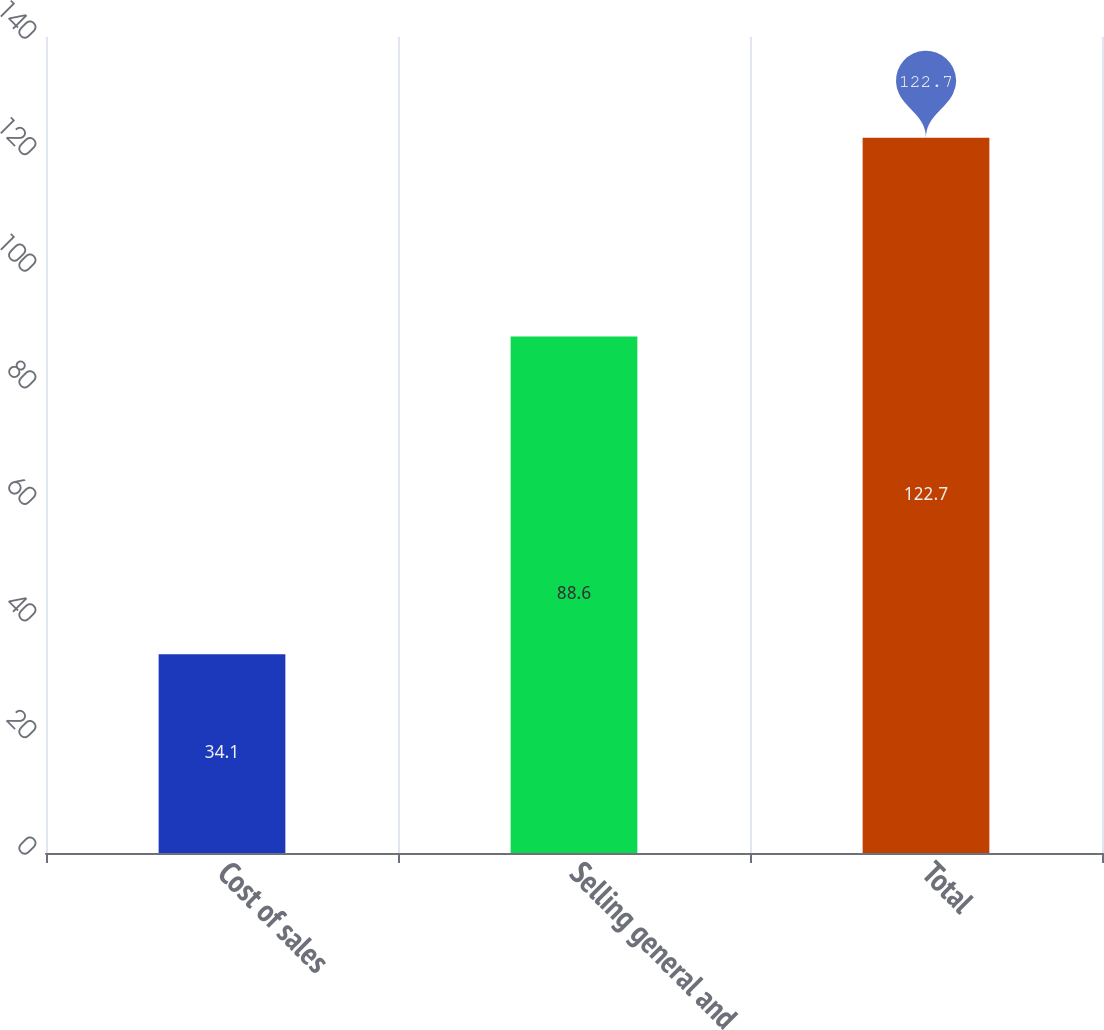Convert chart. <chart><loc_0><loc_0><loc_500><loc_500><bar_chart><fcel>Cost of sales<fcel>Selling general and<fcel>Total<nl><fcel>34.1<fcel>88.6<fcel>122.7<nl></chart> 